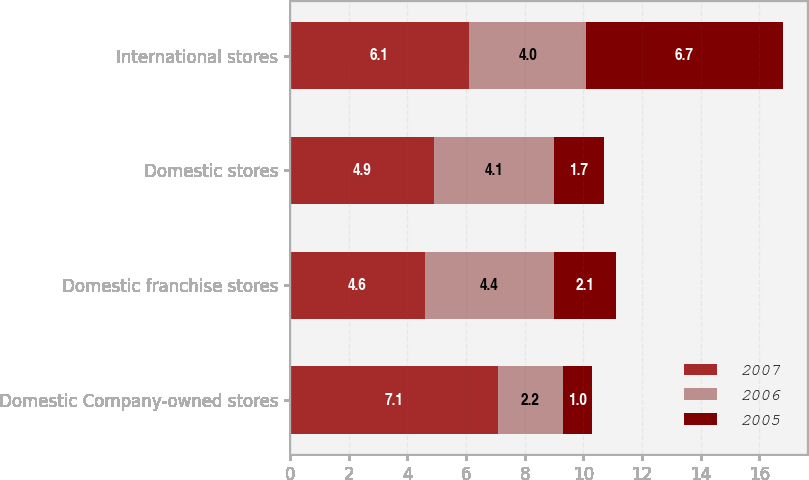Convert chart to OTSL. <chart><loc_0><loc_0><loc_500><loc_500><stacked_bar_chart><ecel><fcel>Domestic Company-owned stores<fcel>Domestic franchise stores<fcel>Domestic stores<fcel>International stores<nl><fcel>2007<fcel>7.1<fcel>4.6<fcel>4.9<fcel>6.1<nl><fcel>2006<fcel>2.2<fcel>4.4<fcel>4.1<fcel>4<nl><fcel>2005<fcel>1<fcel>2.1<fcel>1.7<fcel>6.7<nl></chart> 